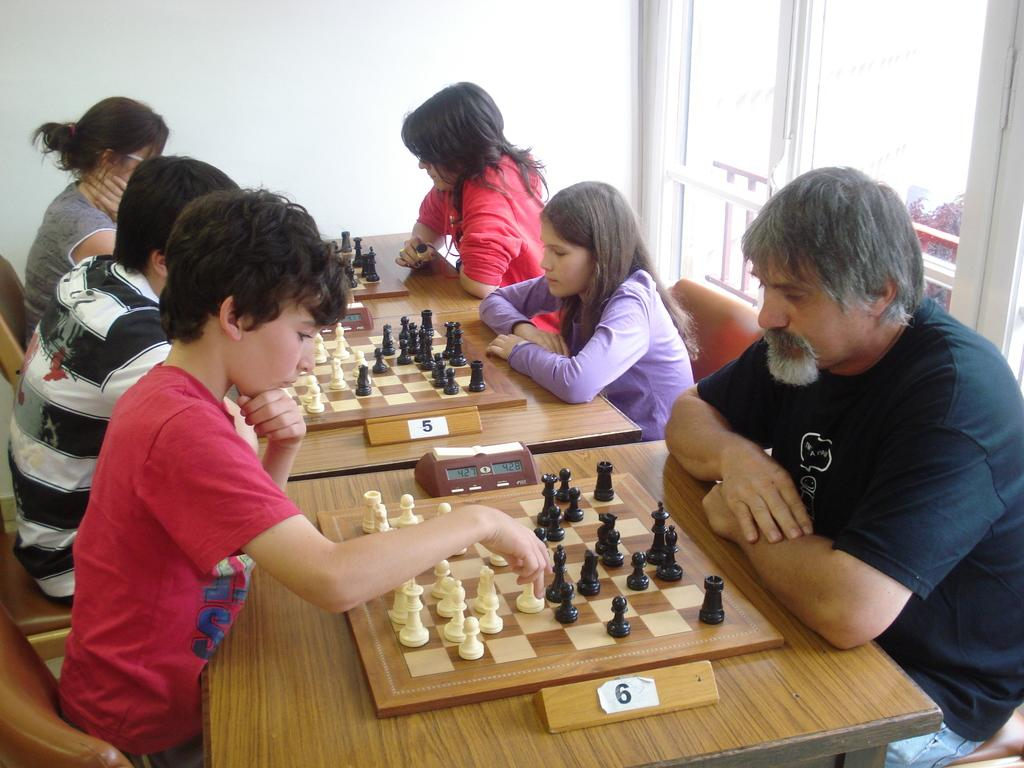What activity are the people in the image engaged in? The people in the image are playing chess. How are the people positioned while playing chess? The people are facing their opponents while playing chess. What type of smoke can be seen coming from the chess pieces in the image? There is no smoke present in the image; it features a group of people playing chess. Are there any fairies visible in the image? There are no fairies present in the image; it features a group of people playing chess. 